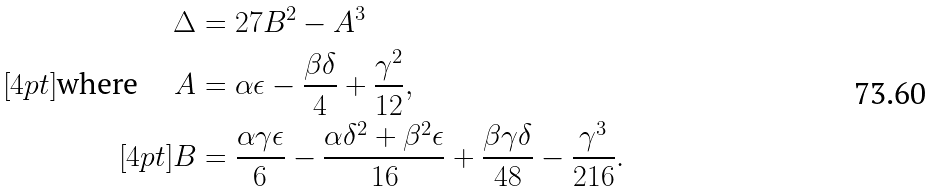<formula> <loc_0><loc_0><loc_500><loc_500>\Delta & = 2 7 B ^ { 2 } - A ^ { 3 } \\ [ 4 p t ] \text {where } \quad A & = \alpha \epsilon - \frac { \beta \delta } { 4 } + \frac { \gamma ^ { 2 } } { 1 2 } , \\ [ 4 p t ] B & = \frac { \alpha \gamma \epsilon } { 6 } - \frac { \alpha \delta ^ { 2 } + \beta ^ { 2 } \epsilon } { 1 6 } + \frac { \beta \gamma \delta } { 4 8 } - \frac { \gamma ^ { 3 } } { 2 1 6 } .</formula> 